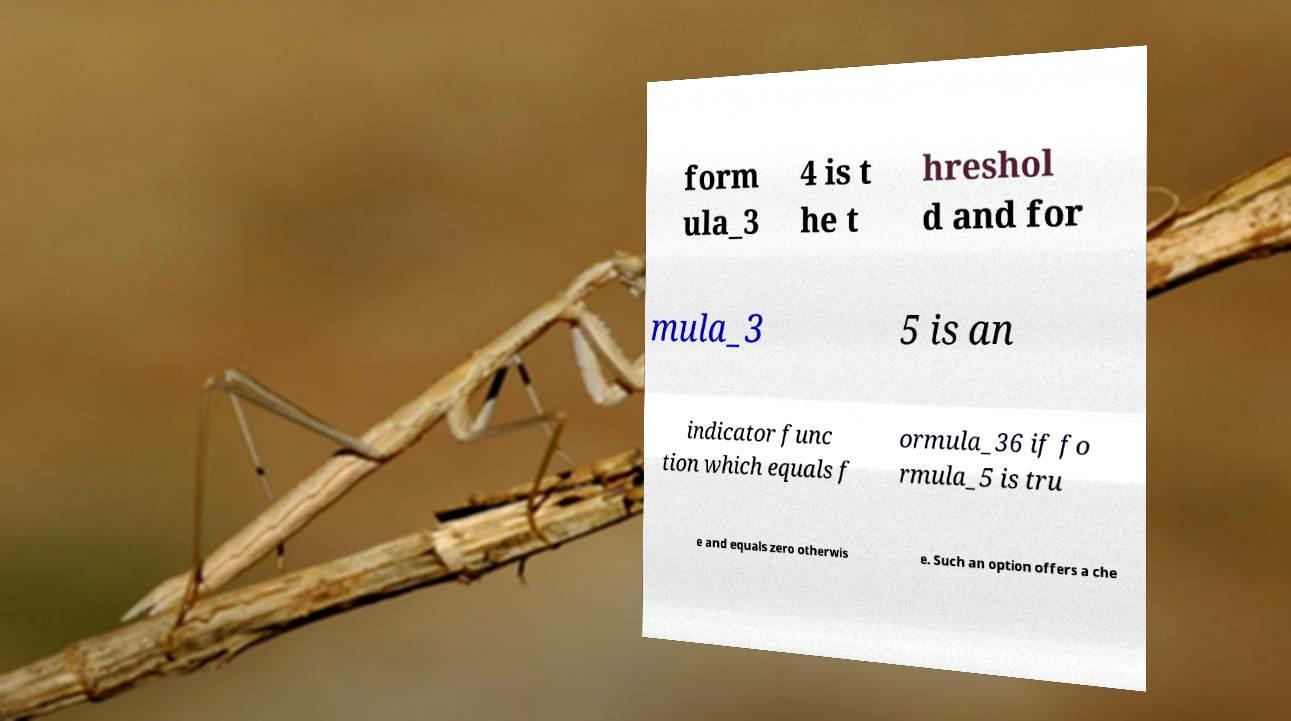For documentation purposes, I need the text within this image transcribed. Could you provide that? form ula_3 4 is t he t hreshol d and for mula_3 5 is an indicator func tion which equals f ormula_36 if fo rmula_5 is tru e and equals zero otherwis e. Such an option offers a che 